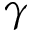<formula> <loc_0><loc_0><loc_500><loc_500>\gamma</formula> 